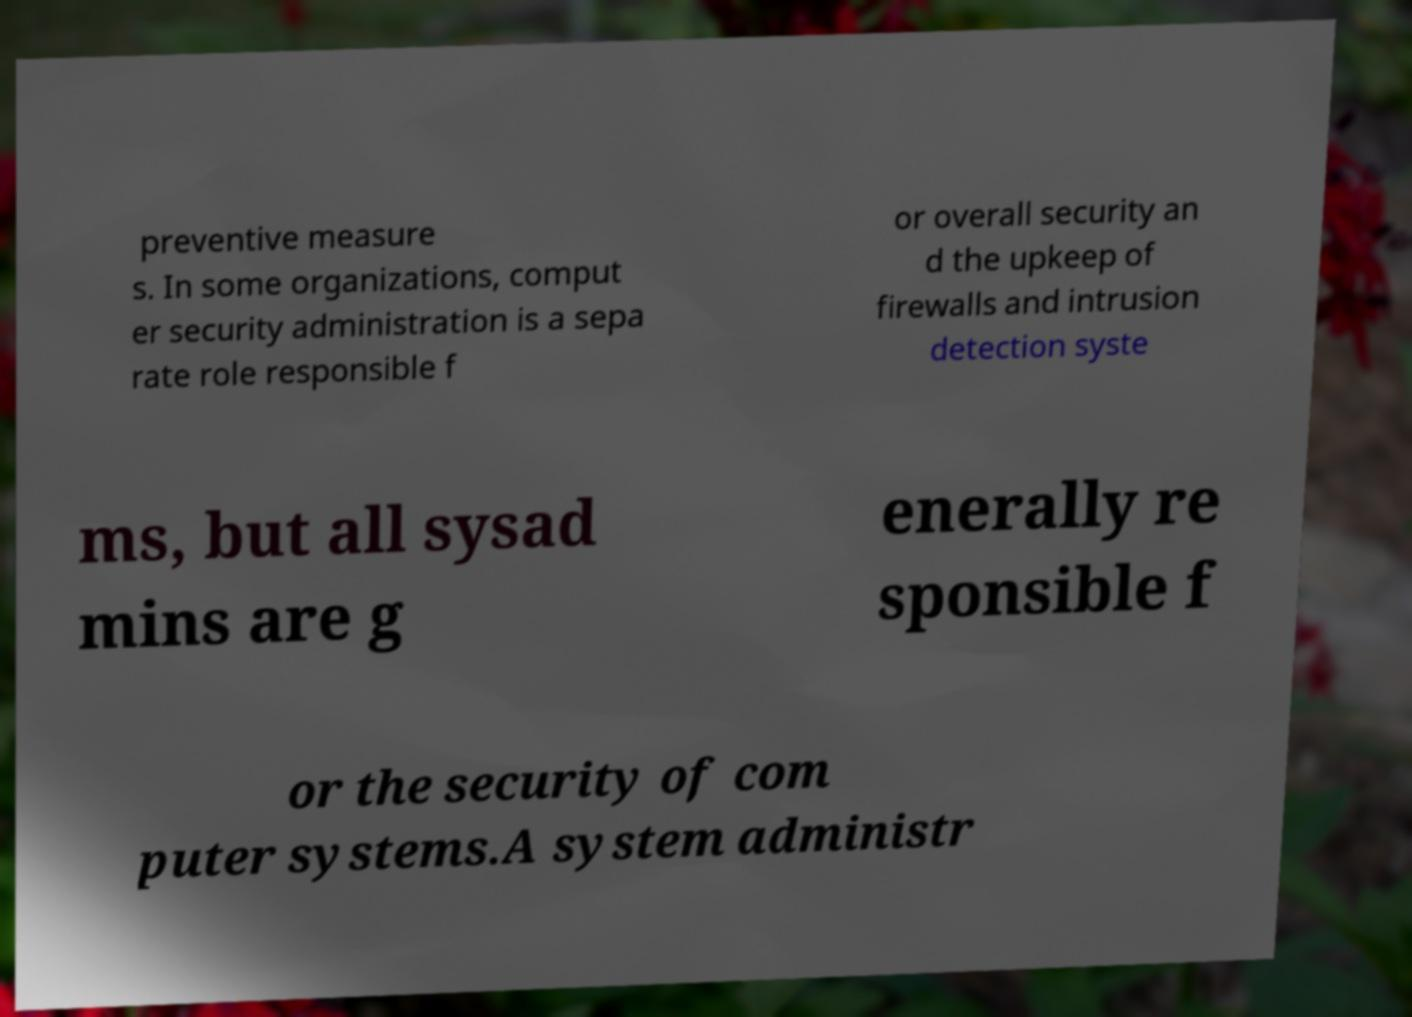Please identify and transcribe the text found in this image. preventive measure s. In some organizations, comput er security administration is a sepa rate role responsible f or overall security an d the upkeep of firewalls and intrusion detection syste ms, but all sysad mins are g enerally re sponsible f or the security of com puter systems.A system administr 